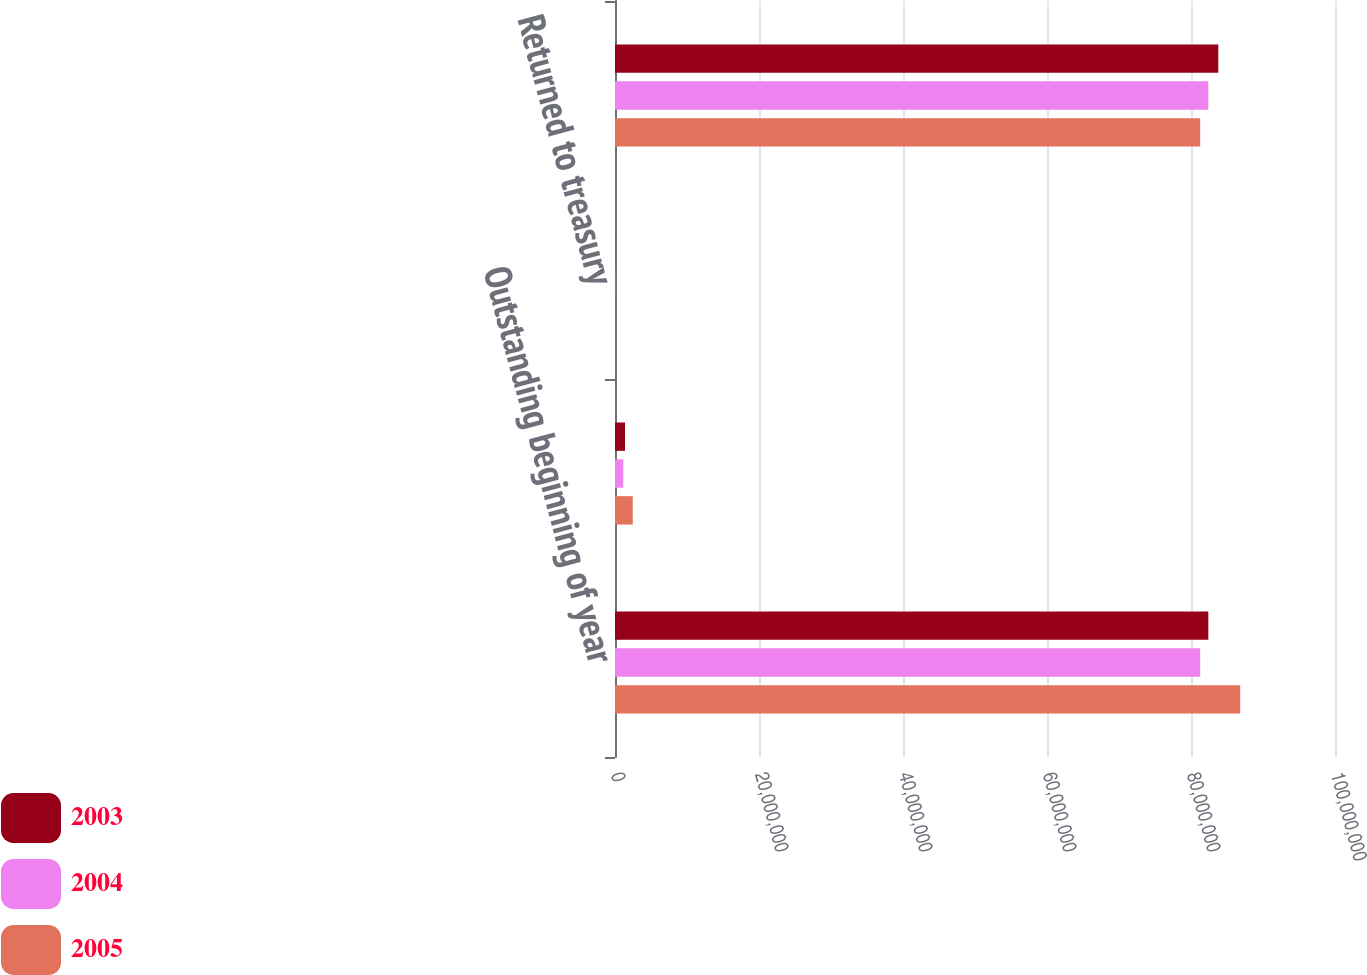Convert chart to OTSL. <chart><loc_0><loc_0><loc_500><loc_500><stacked_bar_chart><ecel><fcel>Outstanding beginning of year<fcel>Issued from treasury<fcel>Returned to treasury<fcel>Outstanding end of year<nl><fcel>2003<fcel>8.24071e+07<fcel>1.38818e+06<fcel>4113<fcel>8.37911e+07<nl><fcel>2004<fcel>8.12768e+07<fcel>1.15158e+06<fcel>21334<fcel>8.24071e+07<nl><fcel>2005<fcel>8.68351e+07<fcel>2.46555e+06<fcel>3077<fcel>8.12768e+07<nl></chart> 